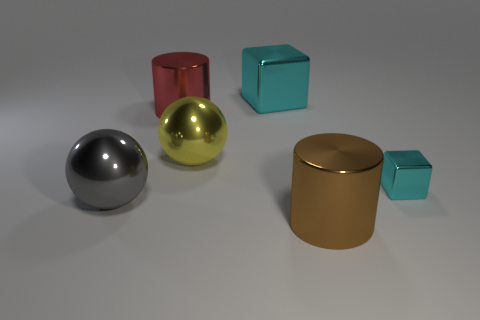Add 1 red shiny cylinders. How many objects exist? 7 Subtract all cylinders. How many objects are left? 4 Add 5 tiny red things. How many tiny red things exist? 5 Subtract 0 purple balls. How many objects are left? 6 Subtract all purple rubber spheres. Subtract all red things. How many objects are left? 5 Add 4 big yellow objects. How many big yellow objects are left? 5 